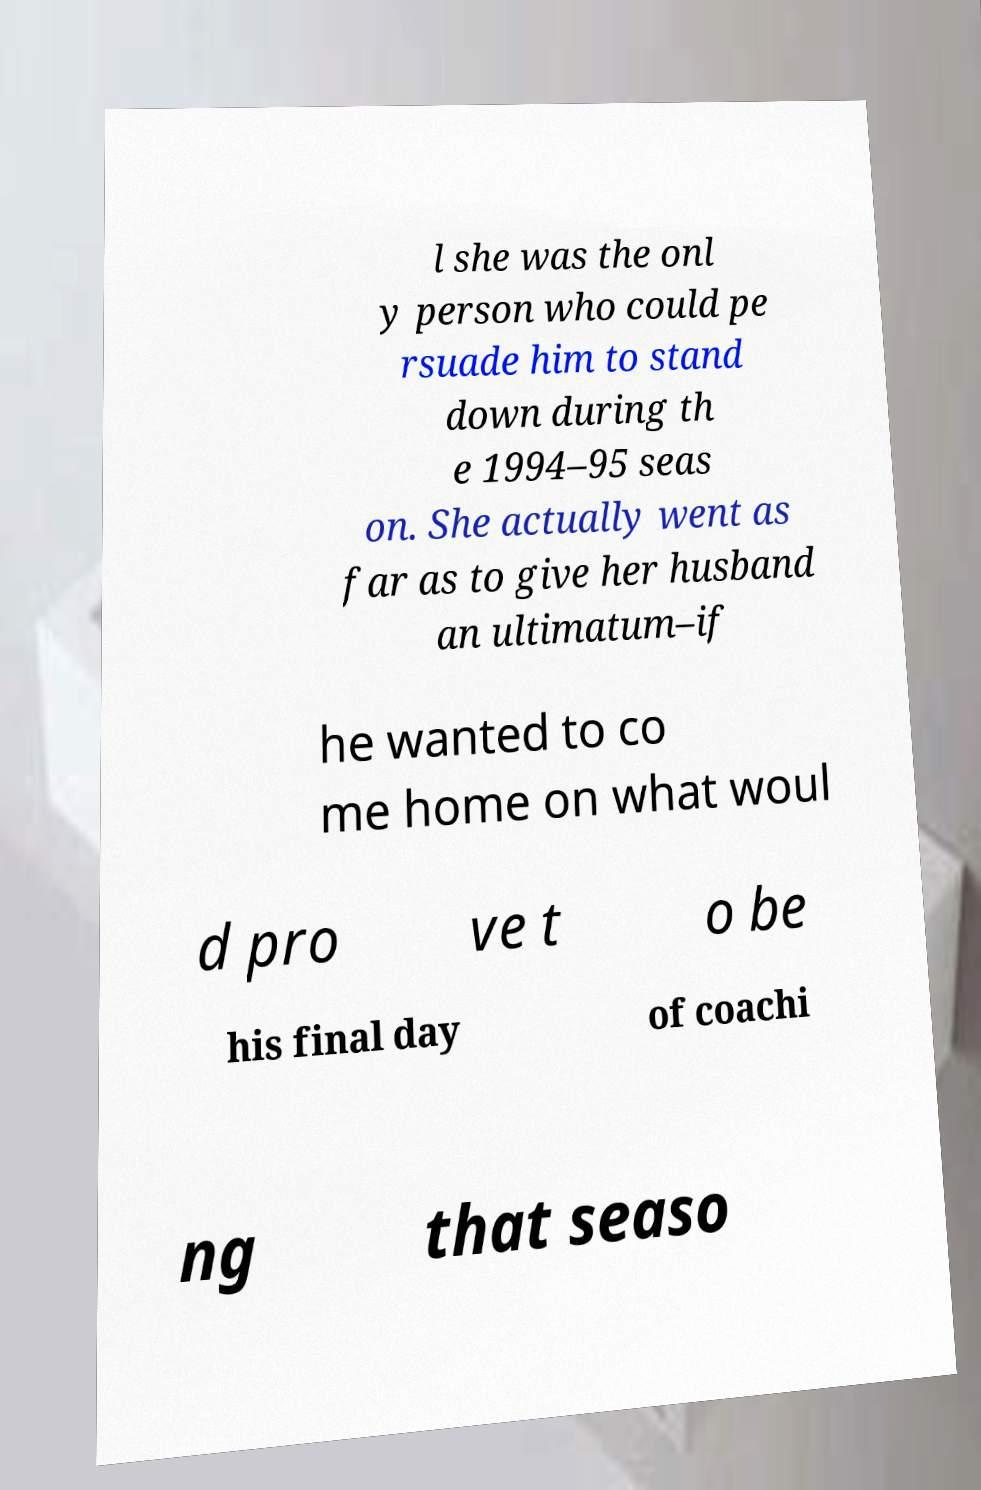What messages or text are displayed in this image? I need them in a readable, typed format. l she was the onl y person who could pe rsuade him to stand down during th e 1994–95 seas on. She actually went as far as to give her husband an ultimatum–if he wanted to co me home on what woul d pro ve t o be his final day of coachi ng that seaso 